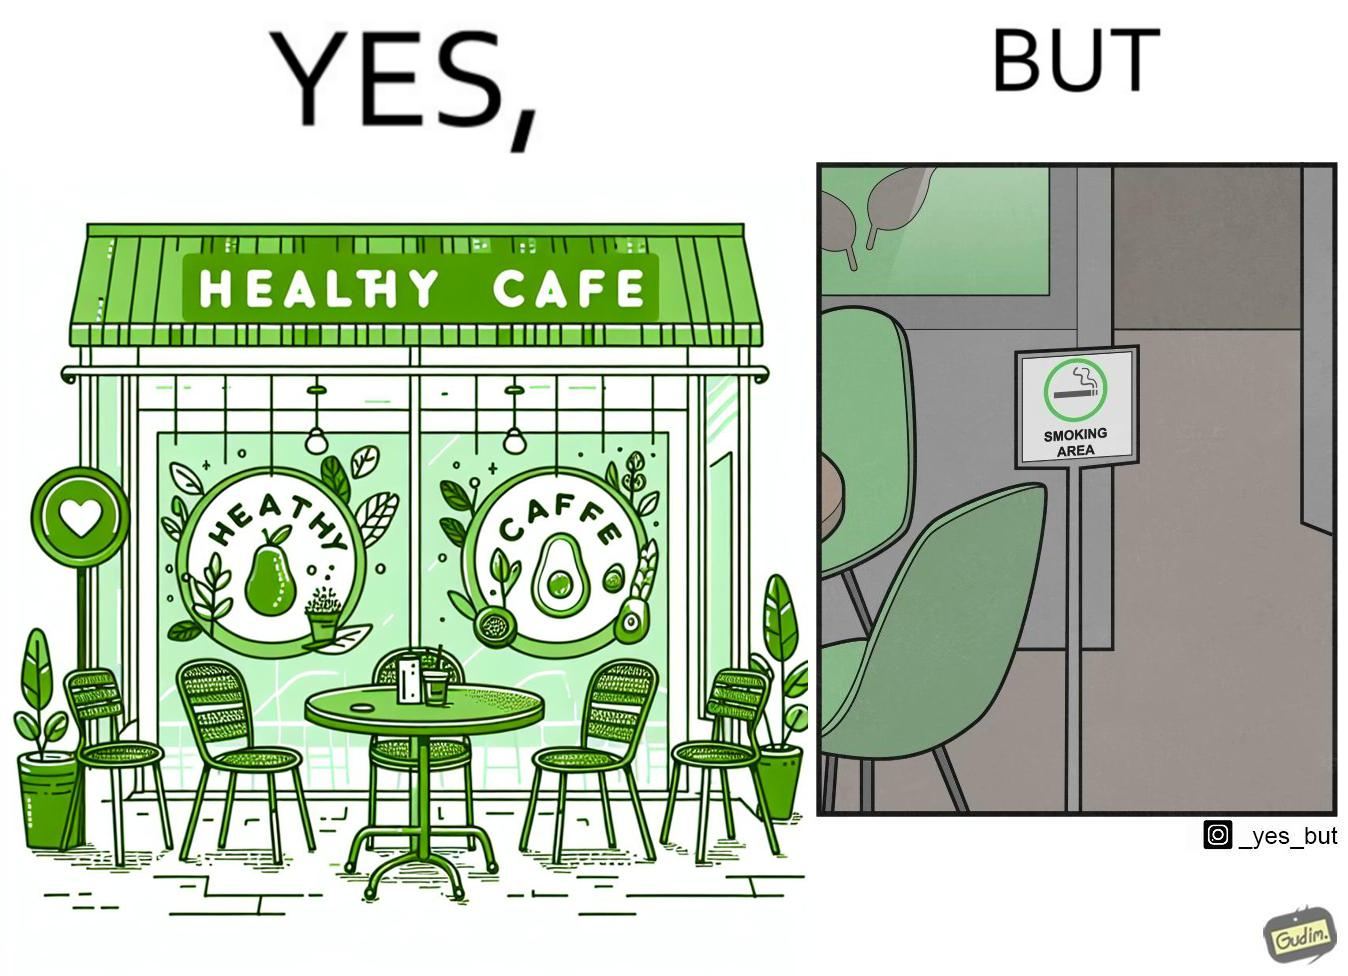Describe the contrast between the left and right parts of this image. In the left part of the image: An eatery with the name "Healthy Cafe". It has a green aesthetic with paintings of leaves, avocados, etc on their windows. They have an outdoor seating area with 4 green patio chairs around a circular table. There is a small sign on a stand near the table with a green circular symbol and some text that is too small to read. In the right part of the image: Green patio chairs. A sign on a stand that has a green circular symbol encircling a cigarette symbol, and some text that says "SMOKING AREA". 